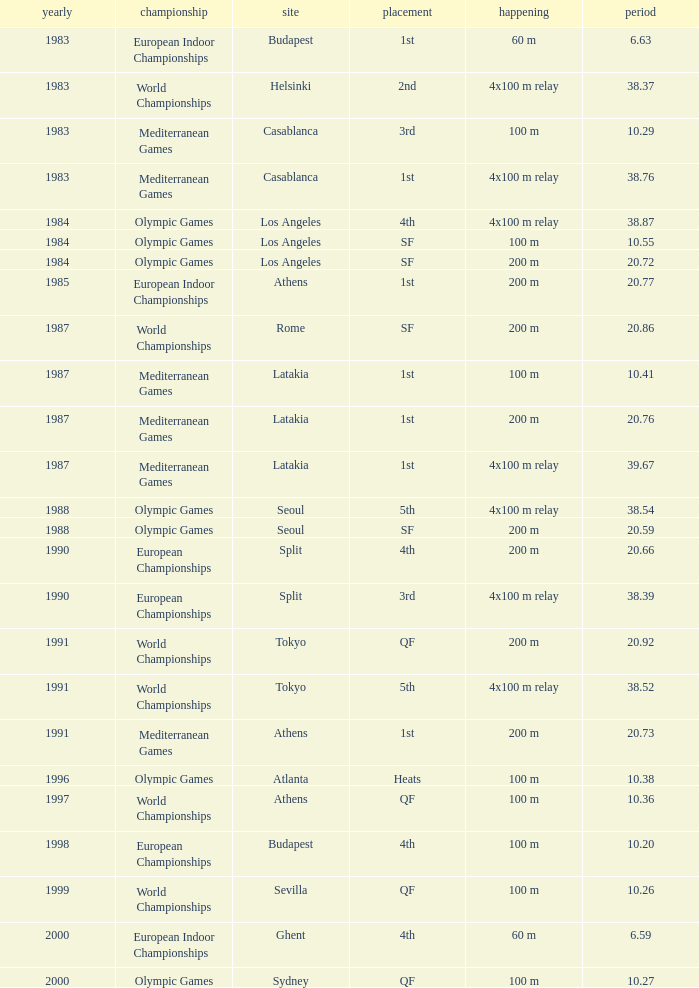What is the greatest Time with a Year of 1991, and Event of 4x100 m relay? 38.52. 